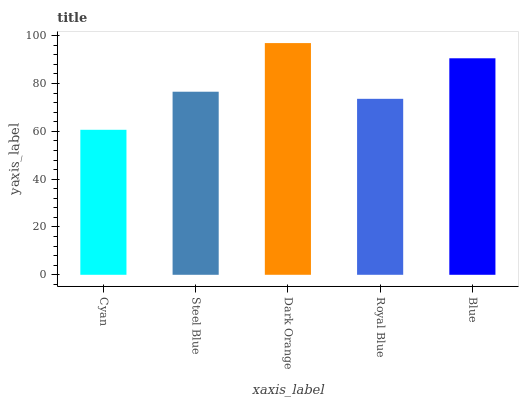Is Steel Blue the minimum?
Answer yes or no. No. Is Steel Blue the maximum?
Answer yes or no. No. Is Steel Blue greater than Cyan?
Answer yes or no. Yes. Is Cyan less than Steel Blue?
Answer yes or no. Yes. Is Cyan greater than Steel Blue?
Answer yes or no. No. Is Steel Blue less than Cyan?
Answer yes or no. No. Is Steel Blue the high median?
Answer yes or no. Yes. Is Steel Blue the low median?
Answer yes or no. Yes. Is Royal Blue the high median?
Answer yes or no. No. Is Blue the low median?
Answer yes or no. No. 